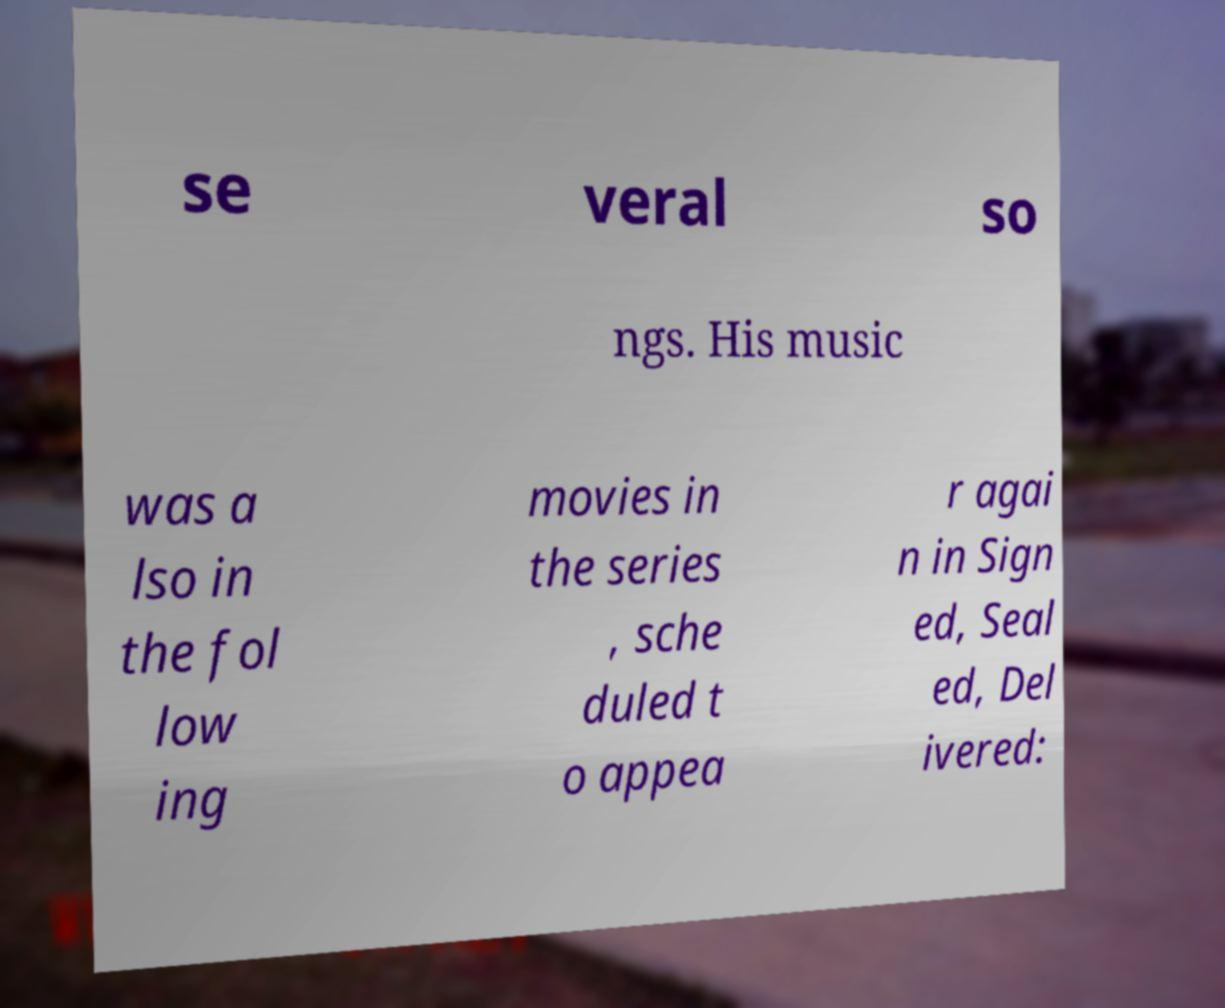For documentation purposes, I need the text within this image transcribed. Could you provide that? se veral so ngs. His music was a lso in the fol low ing movies in the series , sche duled t o appea r agai n in Sign ed, Seal ed, Del ivered: 